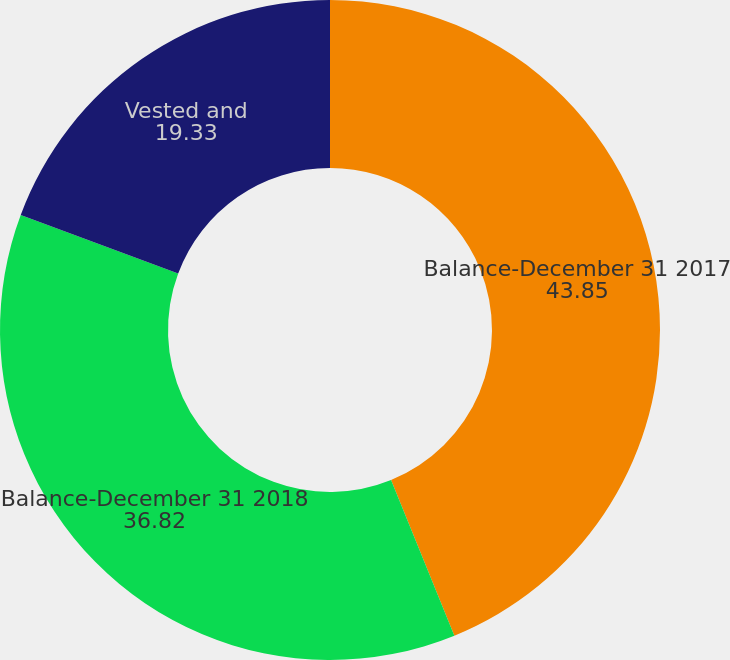Convert chart. <chart><loc_0><loc_0><loc_500><loc_500><pie_chart><fcel>Balance-December 31 2017<fcel>Balance-December 31 2018<fcel>Vested and<nl><fcel>43.85%<fcel>36.82%<fcel>19.33%<nl></chart> 